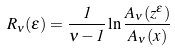Convert formula to latex. <formula><loc_0><loc_0><loc_500><loc_500>R _ { \nu } ( \epsilon ) = \frac { 1 } { \nu - 1 } \ln \frac { A _ { \nu } ( z ^ { \epsilon } ) } { A _ { \nu } ( x ) }</formula> 